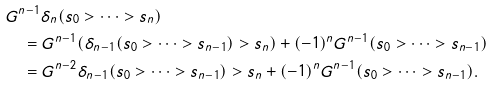Convert formula to latex. <formula><loc_0><loc_0><loc_500><loc_500>& G ^ { n - 1 } \delta _ { n } ( s _ { 0 } > \cdots > s _ { n } ) \\ & \quad = G ^ { n - 1 } ( \delta _ { n - 1 } ( s _ { 0 } > \cdots > s _ { n - 1 } ) > s _ { n } ) + ( - 1 ) ^ { n } G ^ { n - 1 } ( s _ { 0 } > \cdots > s _ { n - 1 } ) \\ & \quad = G ^ { n - 2 } \delta _ { n - 1 } ( s _ { 0 } > \cdots > s _ { n - 1 } ) > s _ { n } + ( - 1 ) ^ { n } G ^ { n - 1 } ( s _ { 0 } > \cdots > s _ { n - 1 } ) .</formula> 